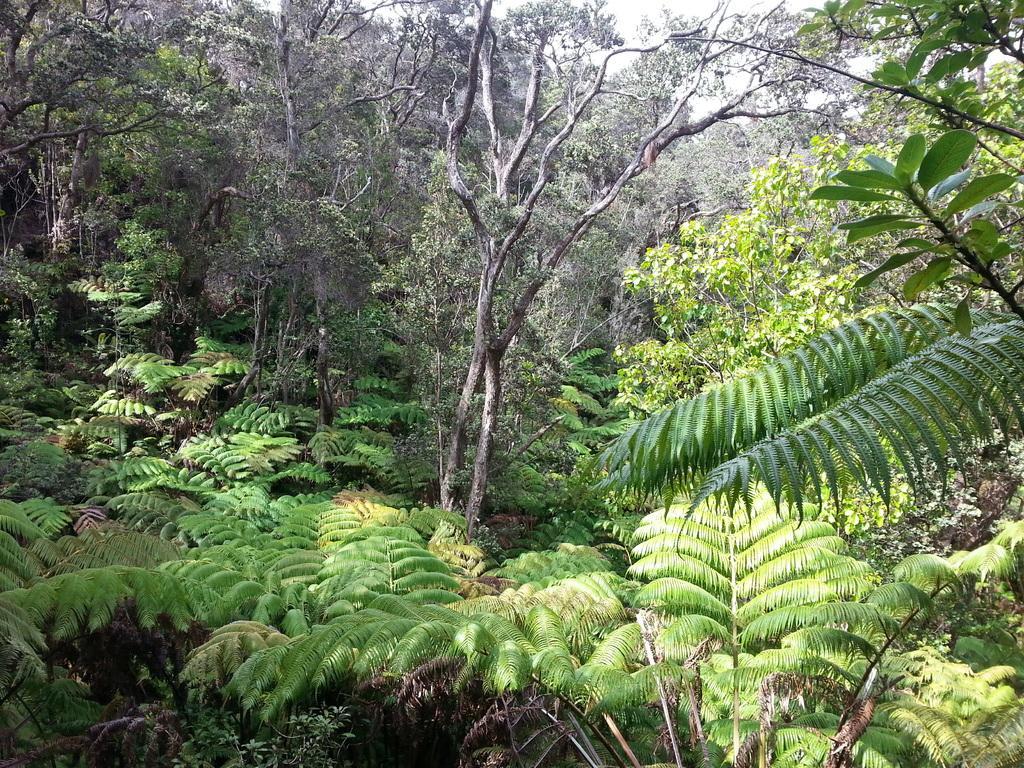Please provide a concise description of this image. In this image we can see plants and trees. At the top of the image, we can see the sky. 